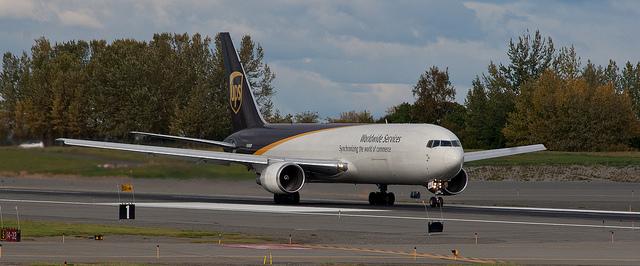Is the plane in motion?
Give a very brief answer. Yes. What color is the plane?
Keep it brief. White. What three letters are on the tail of the plane?
Concise answer only. Ups. Is this plane in motion?
Be succinct. No. How many windows are here?
Short answer required. 4. Is this a cargo plane?
Concise answer only. Yes. 